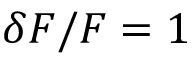Convert formula to latex. <formula><loc_0><loc_0><loc_500><loc_500>\delta F / F = 1 \</formula> 